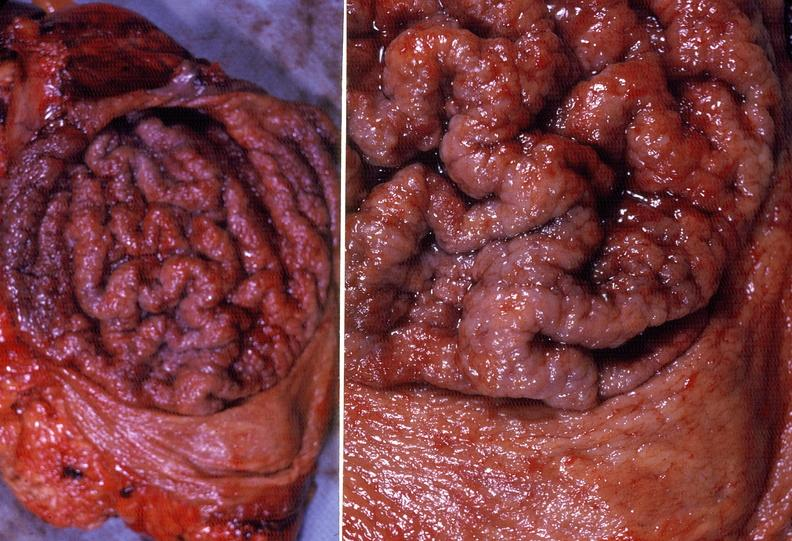does this image show stomach, giant rugose hypertrophy?
Answer the question using a single word or phrase. Yes 